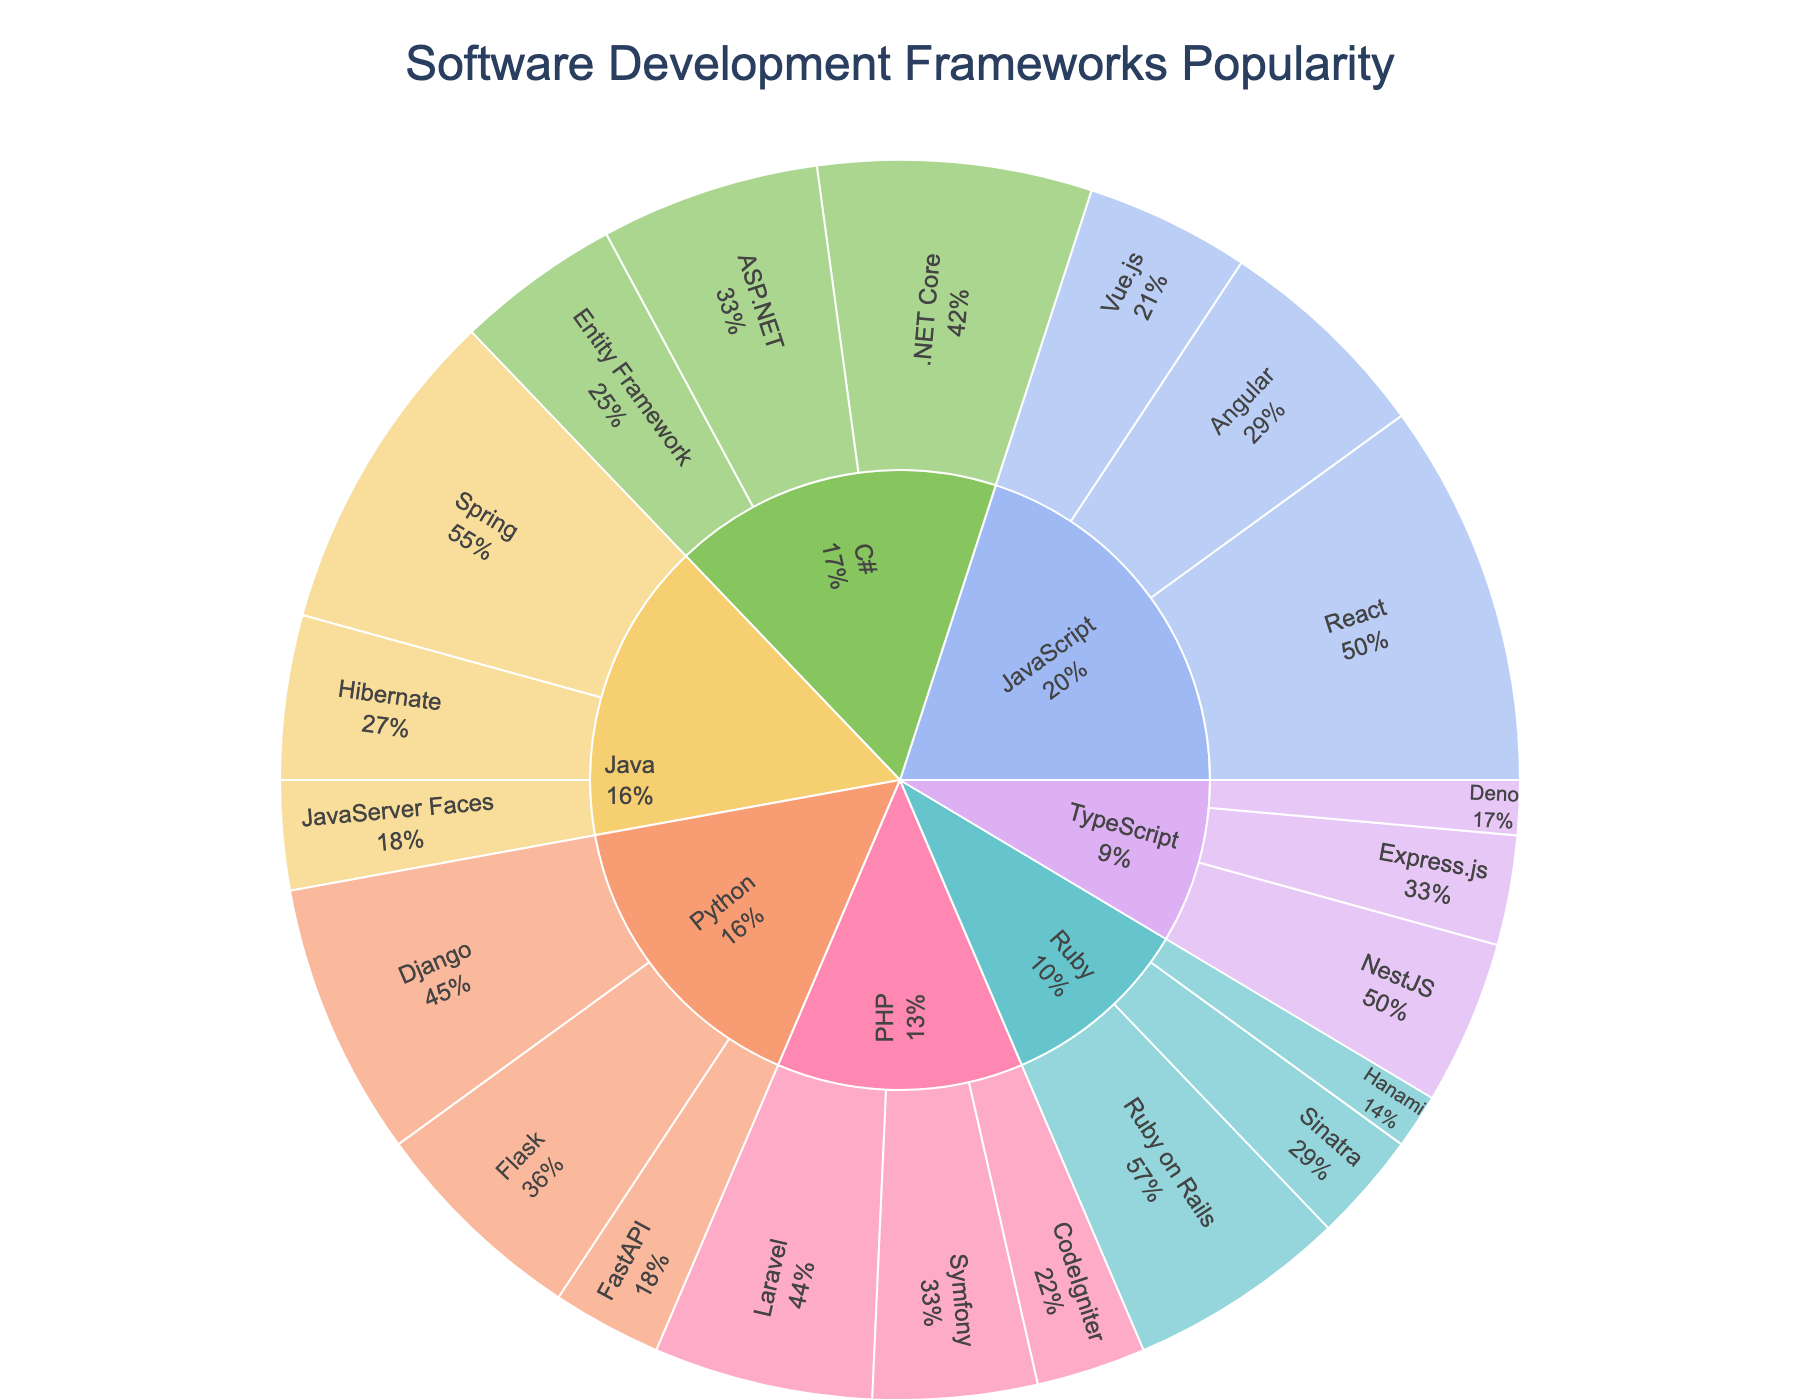What is the title of the sunburst plot? The title of the plot is located at the top of the figure.
Answer: Software Development Frameworks Popularity Which programming language has the highest total popularity across its frameworks? Examine the sum of the popularity values for each language. JavaScript has frameworks with popularity values of 35, 20, and 15, totaling 70, which is the highest among all languages.
Answer: JavaScript What is the most popular framework for Python based on the sunburst plot? Look within the Python section of the sunburst to find the framework with the highest popularity value. Django is listed under Python with a popularity of 25, which is the highest among Python frameworks.
Answer: Django How does the popularity of React compare to Angular? Compare the popularity values directly. React has a popularity of 35 and Angular has 20.
Answer: React is more popular than Angular What is the combined popularity of all TypeScript frameworks? Sum the popularity values of all frameworks listed under TypeScript: 15 (NestJS) + 10 (Express.js) + 5 (Deno). 15 + 10 + 5 = 30.
Answer: 30 What percentage of JavaScript popularity is attributed to Vue.js? First, find the total popularity of JavaScript frameworks, which is 70. Vue.js has a popularity of 15. The percentage is (15/70) * 100 ≈ 21.43%.
Answer: Approximately 21.43% How many frameworks are presented for the Java language? Count the number of unique frameworks listed under the Java section of the sunburst plot. There are three: Spring, Hibernate, and JavaServer Faces.
Answer: 3 Which language's frameworks have the least total popularity? Sum the popularity for each language and compare. Ruby has frameworks with popularity values of 20, 10, and 5, totaling 35, which is the lowest total.
Answer: Ruby What is the average popularity of the frameworks listed under PHP? Sum the popularity values for PHP frameworks and divide by the number of frameworks. The values are 20 (Laravel), 15 (Symfony), and 10 (CodeIgniter). Average = (20 + 15 + 10) / 3 = 45 / 3 = 15.
Answer: 15 Which framework has the least popularity among all displayed in the plot? Identify the framework with the smallest popularity value. Hanami and Deno both have a popularity of 5.
Answer: Hanami and Deno 